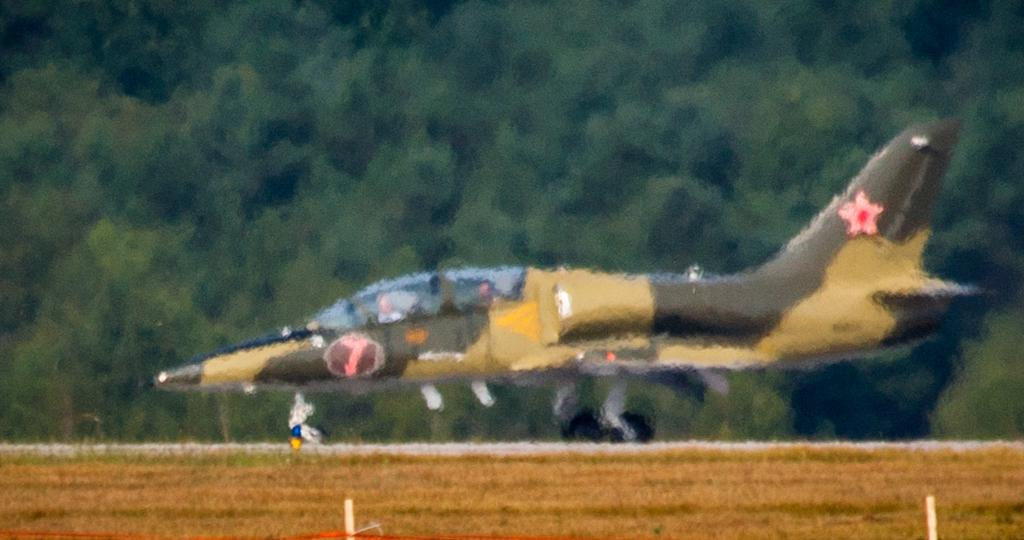What is the main subject in the center of the image? There is an aircraft in the center of the image. What can be seen in the background of the image? There are trees in the background of the image. What type of grain is being sold in the store in the image? There is no store or grain present in the image; it features an aircraft and trees in the background. 